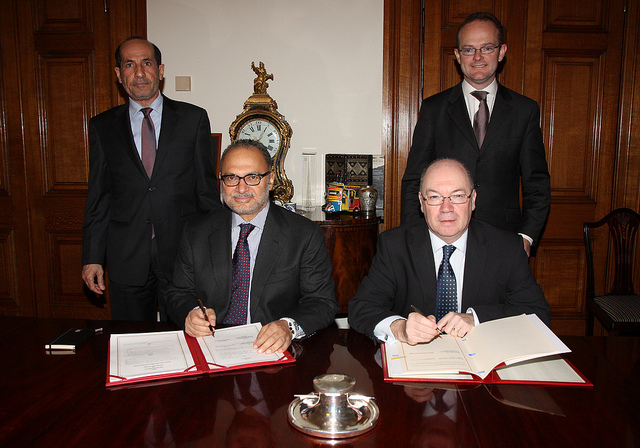What can you infer about the roles of the individuals in the background? The individuals standing in the background, who are observing the document signing, could be colleagues, legal advisors, or witnesses. Their presence implies that they hold roles that are supportive or supervisory in nature. Given the formal dress code and the solemn atmosphere of the occasion, they may be there to confirm the legitimacy and significance of the proceedings, possibly holding positions of authority or expertise. 